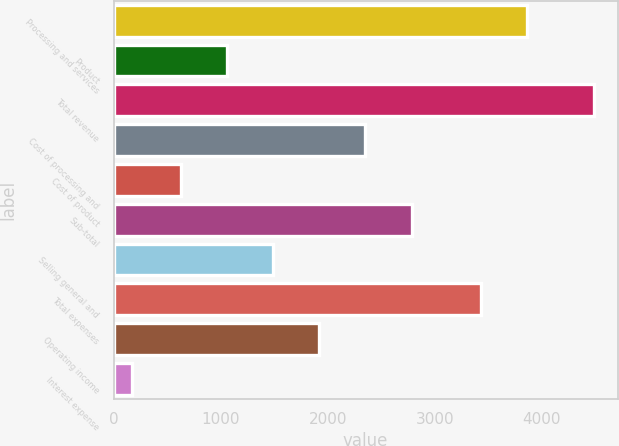Convert chart to OTSL. <chart><loc_0><loc_0><loc_500><loc_500><bar_chart><fcel>Processing and services<fcel>Product<fcel>Total revenue<fcel>Cost of processing and<fcel>Cost of product<fcel>Sub-total<fcel>Selling general and<fcel>Total expenses<fcel>Operating income<fcel>Interest expense<nl><fcel>3856.8<fcel>1058.8<fcel>4482<fcel>2351.2<fcel>628<fcel>2782<fcel>1489.6<fcel>3426<fcel>1920.4<fcel>174<nl></chart> 